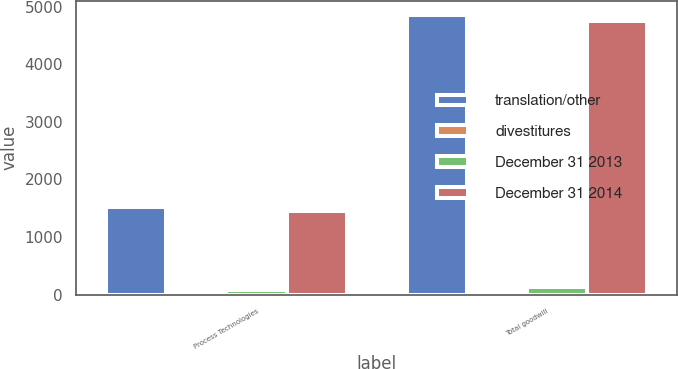Convert chart. <chart><loc_0><loc_0><loc_500><loc_500><stacked_bar_chart><ecel><fcel>Process Technologies<fcel>Total goodwill<nl><fcel>translation/other<fcel>1524.5<fcel>4860.7<nl><fcel>divestitures<fcel>6.8<fcel>6.8<nl><fcel>December 31 2013<fcel>79.8<fcel>125.6<nl><fcel>December 31 2014<fcel>1451.5<fcel>4741.9<nl></chart> 